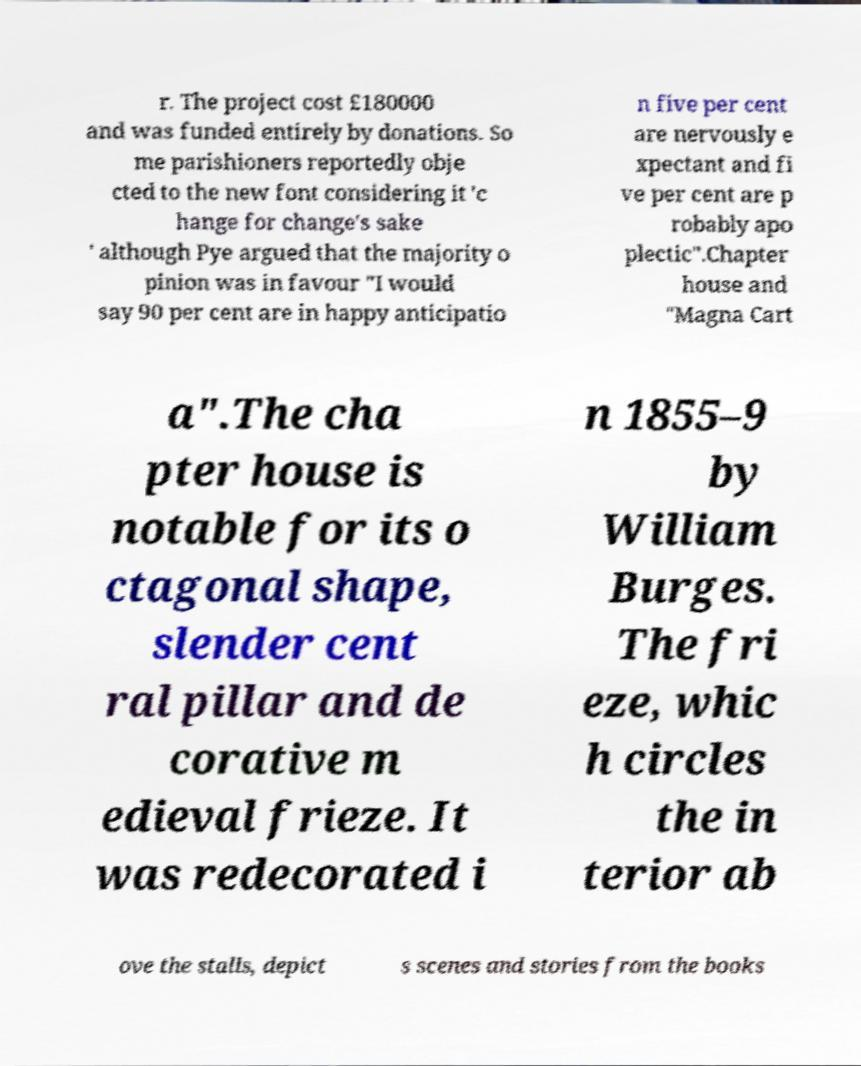Can you read and provide the text displayed in the image?This photo seems to have some interesting text. Can you extract and type it out for me? r. The project cost £180000 and was funded entirely by donations. So me parishioners reportedly obje cted to the new font considering it 'c hange for change's sake ' although Pye argued that the majority o pinion was in favour "I would say 90 per cent are in happy anticipatio n five per cent are nervously e xpectant and fi ve per cent are p robably apo plectic".Chapter house and "Magna Cart a".The cha pter house is notable for its o ctagonal shape, slender cent ral pillar and de corative m edieval frieze. It was redecorated i n 1855–9 by William Burges. The fri eze, whic h circles the in terior ab ove the stalls, depict s scenes and stories from the books 